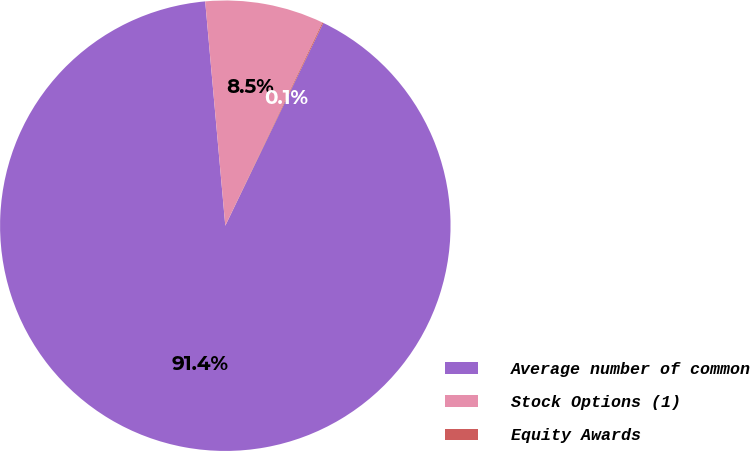<chart> <loc_0><loc_0><loc_500><loc_500><pie_chart><fcel>Average number of common<fcel>Stock Options (1)<fcel>Equity Awards<nl><fcel>91.41%<fcel>8.52%<fcel>0.07%<nl></chart> 